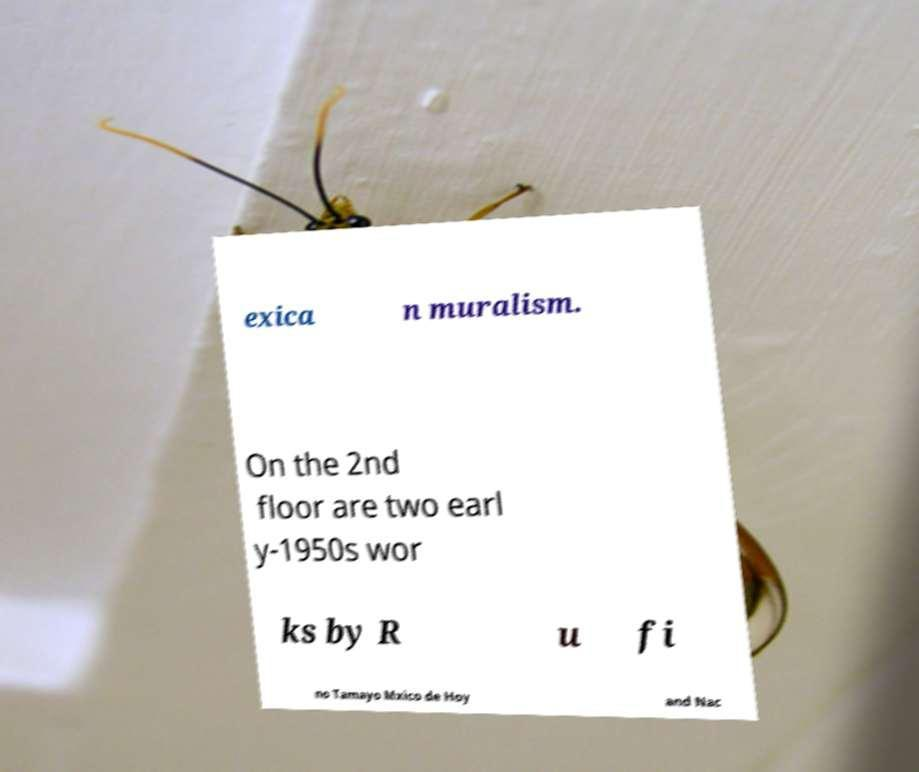Could you extract and type out the text from this image? exica n muralism. On the 2nd floor are two earl y-1950s wor ks by R u fi no Tamayo Mxico de Hoy and Nac 